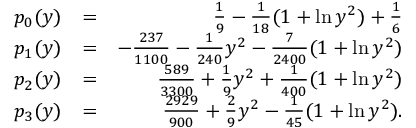<formula> <loc_0><loc_0><loc_500><loc_500>\begin{array} { r l r } { p _ { 0 } ( y ) } & { = } & { \frac { 1 } { 9 } - \frac { 1 } { 1 8 } ( 1 + \ln y ^ { 2 } ) + \frac { 1 } { 6 } } \\ { p _ { 1 } ( y ) } & { = } & { - \frac { 2 3 7 } { 1 1 0 0 } - \frac { 1 } { 2 4 0 } y ^ { 2 } - \frac { 7 } { 2 4 0 0 } ( 1 + \ln y ^ { 2 } ) } \\ { p _ { 2 } ( y ) } & { = } & { \frac { 5 8 9 } { 3 3 0 0 } + \frac { 1 } { 9 } y ^ { 2 } + \frac { 1 } { 4 0 0 } ( 1 + \ln y ^ { 2 } ) } \\ { p _ { 3 } ( y ) } & { = } & { \frac { 2 9 2 9 } { 9 0 0 } + \frac { 2 } { 9 } y ^ { 2 } - \frac { 1 } { 4 5 } ( 1 + \ln y ^ { 2 } ) . } \end{array}</formula> 